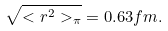<formula> <loc_0><loc_0><loc_500><loc_500>\sqrt { < r ^ { 2 } > _ { \pi } } = 0 . 6 3 f m .</formula> 